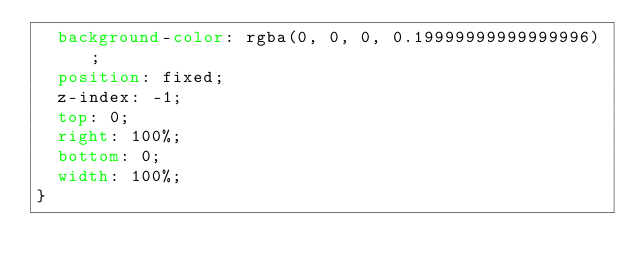Convert code to text. <code><loc_0><loc_0><loc_500><loc_500><_CSS_>  background-color: rgba(0, 0, 0, 0.19999999999999996);
  position: fixed;
  z-index: -1;
  top: 0;
  right: 100%;
  bottom: 0;
  width: 100%;
}
</code> 